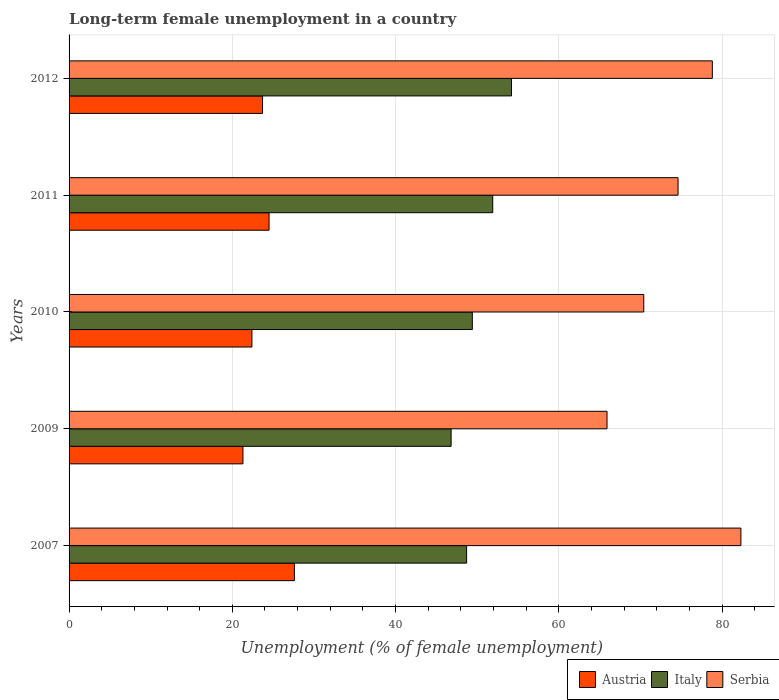How many groups of bars are there?
Offer a terse response. 5. How many bars are there on the 5th tick from the bottom?
Your response must be concise. 3. What is the label of the 2nd group of bars from the top?
Provide a succinct answer. 2011. In how many cases, is the number of bars for a given year not equal to the number of legend labels?
Your answer should be compact. 0. What is the percentage of long-term unemployed female population in Serbia in 2012?
Make the answer very short. 78.8. Across all years, what is the maximum percentage of long-term unemployed female population in Italy?
Ensure brevity in your answer.  54.2. Across all years, what is the minimum percentage of long-term unemployed female population in Serbia?
Your response must be concise. 65.9. In which year was the percentage of long-term unemployed female population in Austria minimum?
Your answer should be very brief. 2009. What is the total percentage of long-term unemployed female population in Austria in the graph?
Your answer should be very brief. 119.5. What is the difference between the percentage of long-term unemployed female population in Austria in 2007 and that in 2010?
Give a very brief answer. 5.2. What is the difference between the percentage of long-term unemployed female population in Serbia in 2010 and the percentage of long-term unemployed female population in Italy in 2007?
Give a very brief answer. 21.7. What is the average percentage of long-term unemployed female population in Italy per year?
Give a very brief answer. 50.2. In the year 2009, what is the difference between the percentage of long-term unemployed female population in Austria and percentage of long-term unemployed female population in Serbia?
Your answer should be very brief. -44.6. What is the ratio of the percentage of long-term unemployed female population in Austria in 2011 to that in 2012?
Provide a short and direct response. 1.03. What is the difference between the highest and the second highest percentage of long-term unemployed female population in Austria?
Provide a short and direct response. 3.1. What is the difference between the highest and the lowest percentage of long-term unemployed female population in Serbia?
Your answer should be compact. 16.4. What does the 1st bar from the top in 2007 represents?
Your answer should be compact. Serbia. What does the 3rd bar from the bottom in 2009 represents?
Your answer should be very brief. Serbia. What is the difference between two consecutive major ticks on the X-axis?
Offer a very short reply. 20. Are the values on the major ticks of X-axis written in scientific E-notation?
Your answer should be very brief. No. Does the graph contain grids?
Offer a very short reply. Yes. What is the title of the graph?
Provide a short and direct response. Long-term female unemployment in a country. What is the label or title of the X-axis?
Offer a terse response. Unemployment (% of female unemployment). What is the label or title of the Y-axis?
Make the answer very short. Years. What is the Unemployment (% of female unemployment) of Austria in 2007?
Offer a very short reply. 27.6. What is the Unemployment (% of female unemployment) of Italy in 2007?
Ensure brevity in your answer.  48.7. What is the Unemployment (% of female unemployment) of Serbia in 2007?
Give a very brief answer. 82.3. What is the Unemployment (% of female unemployment) in Austria in 2009?
Your answer should be very brief. 21.3. What is the Unemployment (% of female unemployment) of Italy in 2009?
Make the answer very short. 46.8. What is the Unemployment (% of female unemployment) of Serbia in 2009?
Keep it short and to the point. 65.9. What is the Unemployment (% of female unemployment) in Austria in 2010?
Provide a short and direct response. 22.4. What is the Unemployment (% of female unemployment) in Italy in 2010?
Ensure brevity in your answer.  49.4. What is the Unemployment (% of female unemployment) of Serbia in 2010?
Your answer should be very brief. 70.4. What is the Unemployment (% of female unemployment) of Austria in 2011?
Your answer should be compact. 24.5. What is the Unemployment (% of female unemployment) in Italy in 2011?
Your response must be concise. 51.9. What is the Unemployment (% of female unemployment) in Serbia in 2011?
Ensure brevity in your answer.  74.6. What is the Unemployment (% of female unemployment) of Austria in 2012?
Offer a very short reply. 23.7. What is the Unemployment (% of female unemployment) of Italy in 2012?
Provide a short and direct response. 54.2. What is the Unemployment (% of female unemployment) in Serbia in 2012?
Your answer should be very brief. 78.8. Across all years, what is the maximum Unemployment (% of female unemployment) in Austria?
Give a very brief answer. 27.6. Across all years, what is the maximum Unemployment (% of female unemployment) in Italy?
Your answer should be very brief. 54.2. Across all years, what is the maximum Unemployment (% of female unemployment) of Serbia?
Your response must be concise. 82.3. Across all years, what is the minimum Unemployment (% of female unemployment) in Austria?
Your response must be concise. 21.3. Across all years, what is the minimum Unemployment (% of female unemployment) in Italy?
Ensure brevity in your answer.  46.8. Across all years, what is the minimum Unemployment (% of female unemployment) of Serbia?
Ensure brevity in your answer.  65.9. What is the total Unemployment (% of female unemployment) of Austria in the graph?
Keep it short and to the point. 119.5. What is the total Unemployment (% of female unemployment) of Italy in the graph?
Your answer should be compact. 251. What is the total Unemployment (% of female unemployment) in Serbia in the graph?
Provide a succinct answer. 372. What is the difference between the Unemployment (% of female unemployment) of Italy in 2007 and that in 2009?
Ensure brevity in your answer.  1.9. What is the difference between the Unemployment (% of female unemployment) in Serbia in 2007 and that in 2009?
Offer a very short reply. 16.4. What is the difference between the Unemployment (% of female unemployment) in Austria in 2007 and that in 2011?
Your answer should be compact. 3.1. What is the difference between the Unemployment (% of female unemployment) of Italy in 2007 and that in 2011?
Your answer should be compact. -3.2. What is the difference between the Unemployment (% of female unemployment) of Serbia in 2007 and that in 2011?
Ensure brevity in your answer.  7.7. What is the difference between the Unemployment (% of female unemployment) in Italy in 2007 and that in 2012?
Make the answer very short. -5.5. What is the difference between the Unemployment (% of female unemployment) of Austria in 2009 and that in 2010?
Your answer should be compact. -1.1. What is the difference between the Unemployment (% of female unemployment) of Italy in 2009 and that in 2010?
Your answer should be very brief. -2.6. What is the difference between the Unemployment (% of female unemployment) of Austria in 2009 and that in 2011?
Make the answer very short. -3.2. What is the difference between the Unemployment (% of female unemployment) in Serbia in 2009 and that in 2011?
Your response must be concise. -8.7. What is the difference between the Unemployment (% of female unemployment) in Austria in 2009 and that in 2012?
Your answer should be compact. -2.4. What is the difference between the Unemployment (% of female unemployment) in Serbia in 2009 and that in 2012?
Your response must be concise. -12.9. What is the difference between the Unemployment (% of female unemployment) in Italy in 2010 and that in 2011?
Provide a short and direct response. -2.5. What is the difference between the Unemployment (% of female unemployment) in Serbia in 2010 and that in 2011?
Provide a succinct answer. -4.2. What is the difference between the Unemployment (% of female unemployment) in Italy in 2010 and that in 2012?
Your answer should be very brief. -4.8. What is the difference between the Unemployment (% of female unemployment) in Serbia in 2010 and that in 2012?
Your answer should be very brief. -8.4. What is the difference between the Unemployment (% of female unemployment) of Austria in 2011 and that in 2012?
Keep it short and to the point. 0.8. What is the difference between the Unemployment (% of female unemployment) in Italy in 2011 and that in 2012?
Keep it short and to the point. -2.3. What is the difference between the Unemployment (% of female unemployment) of Austria in 2007 and the Unemployment (% of female unemployment) of Italy in 2009?
Provide a succinct answer. -19.2. What is the difference between the Unemployment (% of female unemployment) of Austria in 2007 and the Unemployment (% of female unemployment) of Serbia in 2009?
Ensure brevity in your answer.  -38.3. What is the difference between the Unemployment (% of female unemployment) in Italy in 2007 and the Unemployment (% of female unemployment) in Serbia in 2009?
Provide a short and direct response. -17.2. What is the difference between the Unemployment (% of female unemployment) of Austria in 2007 and the Unemployment (% of female unemployment) of Italy in 2010?
Your answer should be very brief. -21.8. What is the difference between the Unemployment (% of female unemployment) of Austria in 2007 and the Unemployment (% of female unemployment) of Serbia in 2010?
Provide a short and direct response. -42.8. What is the difference between the Unemployment (% of female unemployment) in Italy in 2007 and the Unemployment (% of female unemployment) in Serbia in 2010?
Provide a succinct answer. -21.7. What is the difference between the Unemployment (% of female unemployment) of Austria in 2007 and the Unemployment (% of female unemployment) of Italy in 2011?
Ensure brevity in your answer.  -24.3. What is the difference between the Unemployment (% of female unemployment) in Austria in 2007 and the Unemployment (% of female unemployment) in Serbia in 2011?
Offer a terse response. -47. What is the difference between the Unemployment (% of female unemployment) of Italy in 2007 and the Unemployment (% of female unemployment) of Serbia in 2011?
Offer a very short reply. -25.9. What is the difference between the Unemployment (% of female unemployment) in Austria in 2007 and the Unemployment (% of female unemployment) in Italy in 2012?
Your answer should be very brief. -26.6. What is the difference between the Unemployment (% of female unemployment) of Austria in 2007 and the Unemployment (% of female unemployment) of Serbia in 2012?
Your answer should be compact. -51.2. What is the difference between the Unemployment (% of female unemployment) in Italy in 2007 and the Unemployment (% of female unemployment) in Serbia in 2012?
Keep it short and to the point. -30.1. What is the difference between the Unemployment (% of female unemployment) of Austria in 2009 and the Unemployment (% of female unemployment) of Italy in 2010?
Offer a terse response. -28.1. What is the difference between the Unemployment (% of female unemployment) in Austria in 2009 and the Unemployment (% of female unemployment) in Serbia in 2010?
Your answer should be compact. -49.1. What is the difference between the Unemployment (% of female unemployment) in Italy in 2009 and the Unemployment (% of female unemployment) in Serbia in 2010?
Your response must be concise. -23.6. What is the difference between the Unemployment (% of female unemployment) in Austria in 2009 and the Unemployment (% of female unemployment) in Italy in 2011?
Provide a short and direct response. -30.6. What is the difference between the Unemployment (% of female unemployment) of Austria in 2009 and the Unemployment (% of female unemployment) of Serbia in 2011?
Make the answer very short. -53.3. What is the difference between the Unemployment (% of female unemployment) in Italy in 2009 and the Unemployment (% of female unemployment) in Serbia in 2011?
Keep it short and to the point. -27.8. What is the difference between the Unemployment (% of female unemployment) in Austria in 2009 and the Unemployment (% of female unemployment) in Italy in 2012?
Your answer should be very brief. -32.9. What is the difference between the Unemployment (% of female unemployment) of Austria in 2009 and the Unemployment (% of female unemployment) of Serbia in 2012?
Your response must be concise. -57.5. What is the difference between the Unemployment (% of female unemployment) of Italy in 2009 and the Unemployment (% of female unemployment) of Serbia in 2012?
Provide a succinct answer. -32. What is the difference between the Unemployment (% of female unemployment) of Austria in 2010 and the Unemployment (% of female unemployment) of Italy in 2011?
Your answer should be compact. -29.5. What is the difference between the Unemployment (% of female unemployment) in Austria in 2010 and the Unemployment (% of female unemployment) in Serbia in 2011?
Offer a very short reply. -52.2. What is the difference between the Unemployment (% of female unemployment) of Italy in 2010 and the Unemployment (% of female unemployment) of Serbia in 2011?
Make the answer very short. -25.2. What is the difference between the Unemployment (% of female unemployment) in Austria in 2010 and the Unemployment (% of female unemployment) in Italy in 2012?
Provide a short and direct response. -31.8. What is the difference between the Unemployment (% of female unemployment) in Austria in 2010 and the Unemployment (% of female unemployment) in Serbia in 2012?
Keep it short and to the point. -56.4. What is the difference between the Unemployment (% of female unemployment) in Italy in 2010 and the Unemployment (% of female unemployment) in Serbia in 2012?
Offer a terse response. -29.4. What is the difference between the Unemployment (% of female unemployment) in Austria in 2011 and the Unemployment (% of female unemployment) in Italy in 2012?
Offer a very short reply. -29.7. What is the difference between the Unemployment (% of female unemployment) of Austria in 2011 and the Unemployment (% of female unemployment) of Serbia in 2012?
Your response must be concise. -54.3. What is the difference between the Unemployment (% of female unemployment) of Italy in 2011 and the Unemployment (% of female unemployment) of Serbia in 2012?
Provide a succinct answer. -26.9. What is the average Unemployment (% of female unemployment) of Austria per year?
Offer a very short reply. 23.9. What is the average Unemployment (% of female unemployment) of Italy per year?
Provide a short and direct response. 50.2. What is the average Unemployment (% of female unemployment) in Serbia per year?
Provide a short and direct response. 74.4. In the year 2007, what is the difference between the Unemployment (% of female unemployment) in Austria and Unemployment (% of female unemployment) in Italy?
Your answer should be compact. -21.1. In the year 2007, what is the difference between the Unemployment (% of female unemployment) of Austria and Unemployment (% of female unemployment) of Serbia?
Offer a terse response. -54.7. In the year 2007, what is the difference between the Unemployment (% of female unemployment) in Italy and Unemployment (% of female unemployment) in Serbia?
Your answer should be very brief. -33.6. In the year 2009, what is the difference between the Unemployment (% of female unemployment) of Austria and Unemployment (% of female unemployment) of Italy?
Keep it short and to the point. -25.5. In the year 2009, what is the difference between the Unemployment (% of female unemployment) in Austria and Unemployment (% of female unemployment) in Serbia?
Offer a terse response. -44.6. In the year 2009, what is the difference between the Unemployment (% of female unemployment) in Italy and Unemployment (% of female unemployment) in Serbia?
Offer a very short reply. -19.1. In the year 2010, what is the difference between the Unemployment (% of female unemployment) of Austria and Unemployment (% of female unemployment) of Italy?
Your answer should be very brief. -27. In the year 2010, what is the difference between the Unemployment (% of female unemployment) of Austria and Unemployment (% of female unemployment) of Serbia?
Provide a short and direct response. -48. In the year 2010, what is the difference between the Unemployment (% of female unemployment) of Italy and Unemployment (% of female unemployment) of Serbia?
Provide a short and direct response. -21. In the year 2011, what is the difference between the Unemployment (% of female unemployment) of Austria and Unemployment (% of female unemployment) of Italy?
Offer a very short reply. -27.4. In the year 2011, what is the difference between the Unemployment (% of female unemployment) in Austria and Unemployment (% of female unemployment) in Serbia?
Provide a succinct answer. -50.1. In the year 2011, what is the difference between the Unemployment (% of female unemployment) of Italy and Unemployment (% of female unemployment) of Serbia?
Offer a very short reply. -22.7. In the year 2012, what is the difference between the Unemployment (% of female unemployment) of Austria and Unemployment (% of female unemployment) of Italy?
Your answer should be compact. -30.5. In the year 2012, what is the difference between the Unemployment (% of female unemployment) of Austria and Unemployment (% of female unemployment) of Serbia?
Your answer should be very brief. -55.1. In the year 2012, what is the difference between the Unemployment (% of female unemployment) of Italy and Unemployment (% of female unemployment) of Serbia?
Ensure brevity in your answer.  -24.6. What is the ratio of the Unemployment (% of female unemployment) in Austria in 2007 to that in 2009?
Keep it short and to the point. 1.3. What is the ratio of the Unemployment (% of female unemployment) in Italy in 2007 to that in 2009?
Your answer should be compact. 1.04. What is the ratio of the Unemployment (% of female unemployment) of Serbia in 2007 to that in 2009?
Keep it short and to the point. 1.25. What is the ratio of the Unemployment (% of female unemployment) in Austria in 2007 to that in 2010?
Offer a terse response. 1.23. What is the ratio of the Unemployment (% of female unemployment) in Italy in 2007 to that in 2010?
Your response must be concise. 0.99. What is the ratio of the Unemployment (% of female unemployment) in Serbia in 2007 to that in 2010?
Provide a short and direct response. 1.17. What is the ratio of the Unemployment (% of female unemployment) in Austria in 2007 to that in 2011?
Make the answer very short. 1.13. What is the ratio of the Unemployment (% of female unemployment) in Italy in 2007 to that in 2011?
Offer a very short reply. 0.94. What is the ratio of the Unemployment (% of female unemployment) of Serbia in 2007 to that in 2011?
Offer a very short reply. 1.1. What is the ratio of the Unemployment (% of female unemployment) in Austria in 2007 to that in 2012?
Your answer should be very brief. 1.16. What is the ratio of the Unemployment (% of female unemployment) of Italy in 2007 to that in 2012?
Provide a short and direct response. 0.9. What is the ratio of the Unemployment (% of female unemployment) in Serbia in 2007 to that in 2012?
Offer a very short reply. 1.04. What is the ratio of the Unemployment (% of female unemployment) of Austria in 2009 to that in 2010?
Make the answer very short. 0.95. What is the ratio of the Unemployment (% of female unemployment) of Italy in 2009 to that in 2010?
Offer a very short reply. 0.95. What is the ratio of the Unemployment (% of female unemployment) in Serbia in 2009 to that in 2010?
Make the answer very short. 0.94. What is the ratio of the Unemployment (% of female unemployment) of Austria in 2009 to that in 2011?
Provide a succinct answer. 0.87. What is the ratio of the Unemployment (% of female unemployment) of Italy in 2009 to that in 2011?
Your answer should be compact. 0.9. What is the ratio of the Unemployment (% of female unemployment) of Serbia in 2009 to that in 2011?
Offer a terse response. 0.88. What is the ratio of the Unemployment (% of female unemployment) in Austria in 2009 to that in 2012?
Offer a very short reply. 0.9. What is the ratio of the Unemployment (% of female unemployment) of Italy in 2009 to that in 2012?
Give a very brief answer. 0.86. What is the ratio of the Unemployment (% of female unemployment) of Serbia in 2009 to that in 2012?
Offer a very short reply. 0.84. What is the ratio of the Unemployment (% of female unemployment) of Austria in 2010 to that in 2011?
Your answer should be compact. 0.91. What is the ratio of the Unemployment (% of female unemployment) of Italy in 2010 to that in 2011?
Make the answer very short. 0.95. What is the ratio of the Unemployment (% of female unemployment) of Serbia in 2010 to that in 2011?
Keep it short and to the point. 0.94. What is the ratio of the Unemployment (% of female unemployment) in Austria in 2010 to that in 2012?
Your response must be concise. 0.95. What is the ratio of the Unemployment (% of female unemployment) in Italy in 2010 to that in 2012?
Provide a short and direct response. 0.91. What is the ratio of the Unemployment (% of female unemployment) in Serbia in 2010 to that in 2012?
Offer a very short reply. 0.89. What is the ratio of the Unemployment (% of female unemployment) in Austria in 2011 to that in 2012?
Give a very brief answer. 1.03. What is the ratio of the Unemployment (% of female unemployment) in Italy in 2011 to that in 2012?
Offer a very short reply. 0.96. What is the ratio of the Unemployment (% of female unemployment) of Serbia in 2011 to that in 2012?
Give a very brief answer. 0.95. What is the difference between the highest and the second highest Unemployment (% of female unemployment) in Austria?
Ensure brevity in your answer.  3.1. What is the difference between the highest and the second highest Unemployment (% of female unemployment) in Serbia?
Provide a succinct answer. 3.5. What is the difference between the highest and the lowest Unemployment (% of female unemployment) in Serbia?
Offer a very short reply. 16.4. 